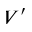Convert formula to latex. <formula><loc_0><loc_0><loc_500><loc_500>V ^ { \prime }</formula> 